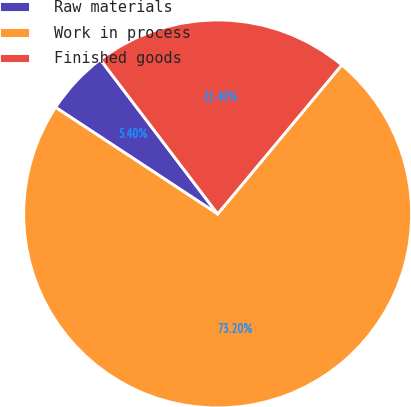<chart> <loc_0><loc_0><loc_500><loc_500><pie_chart><fcel>Raw materials<fcel>Work in process<fcel>Finished goods<nl><fcel>5.4%<fcel>73.2%<fcel>21.4%<nl></chart> 